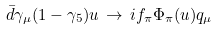Convert formula to latex. <formula><loc_0><loc_0><loc_500><loc_500>\bar { d } \gamma _ { \mu } ( 1 - \gamma _ { 5 } ) u \, \to \, i f _ { \pi } \Phi _ { \pi } ( u ) q _ { \mu }</formula> 